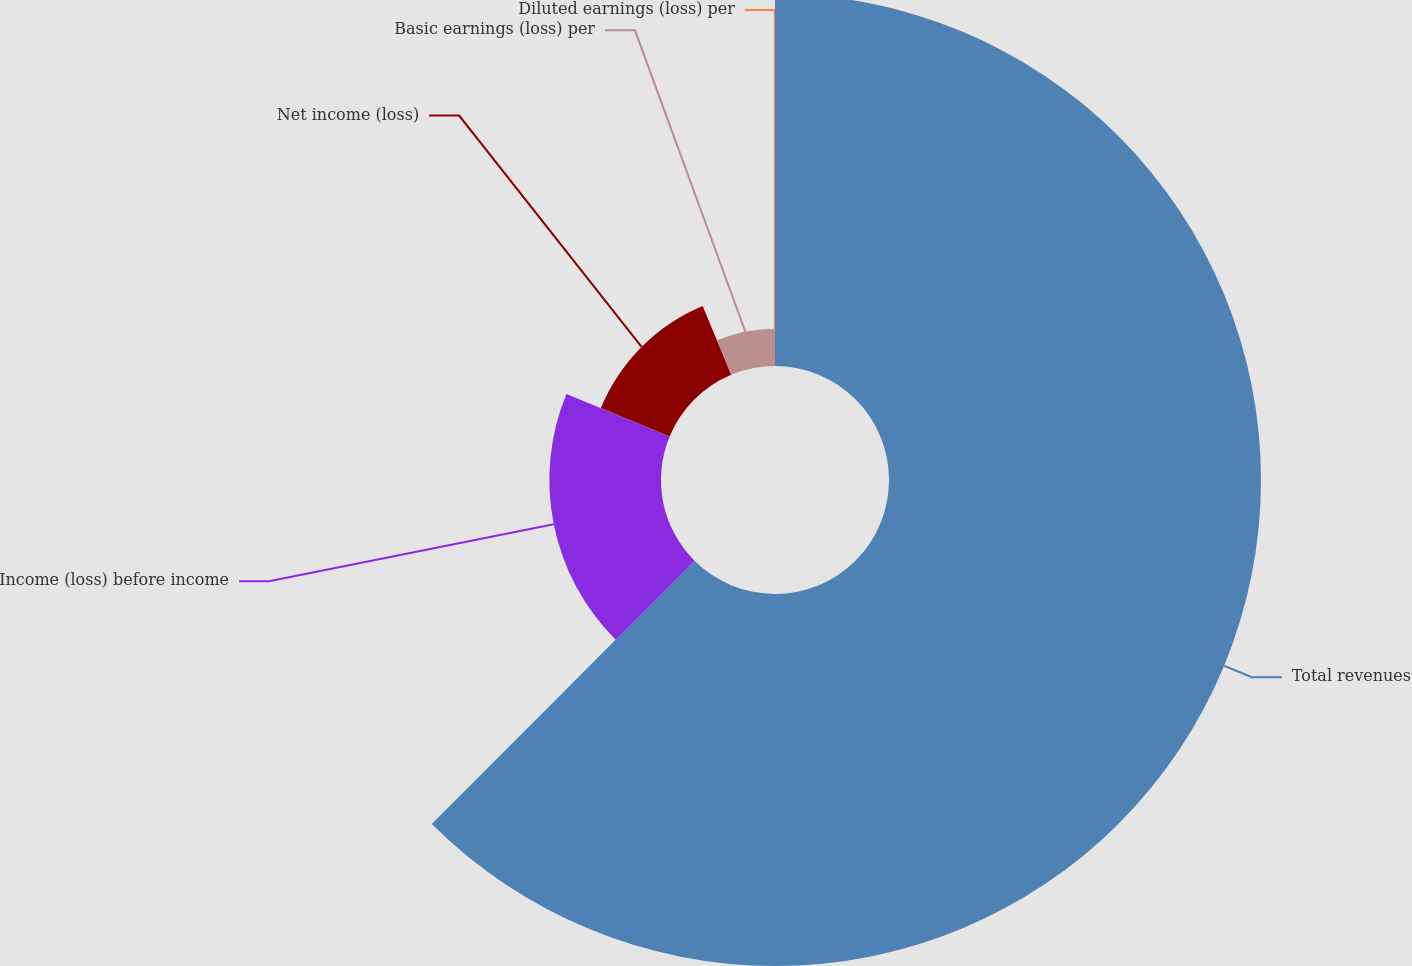<chart> <loc_0><loc_0><loc_500><loc_500><pie_chart><fcel>Total revenues<fcel>Income (loss) before income<fcel>Net income (loss)<fcel>Basic earnings (loss) per<fcel>Diluted earnings (loss) per<nl><fcel>62.48%<fcel>18.75%<fcel>12.5%<fcel>6.26%<fcel>0.01%<nl></chart> 